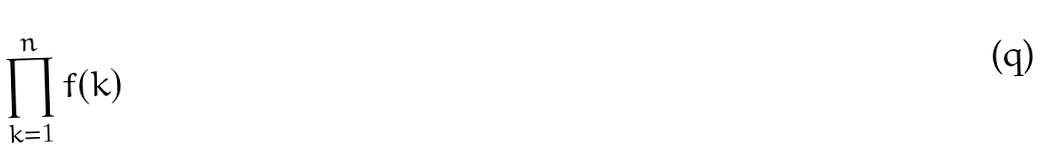Convert formula to latex. <formula><loc_0><loc_0><loc_500><loc_500>\prod _ { k = 1 } ^ { n } f ( k )</formula> 